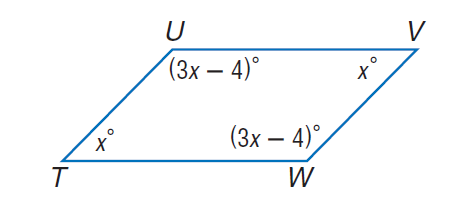Answer the mathemtical geometry problem and directly provide the correct option letter.
Question: Find \angle V.
Choices: A: 44 B: 46 C: 54 D: 134 B 